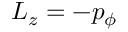<formula> <loc_0><loc_0><loc_500><loc_500>L _ { z } = - p _ { \phi }</formula> 